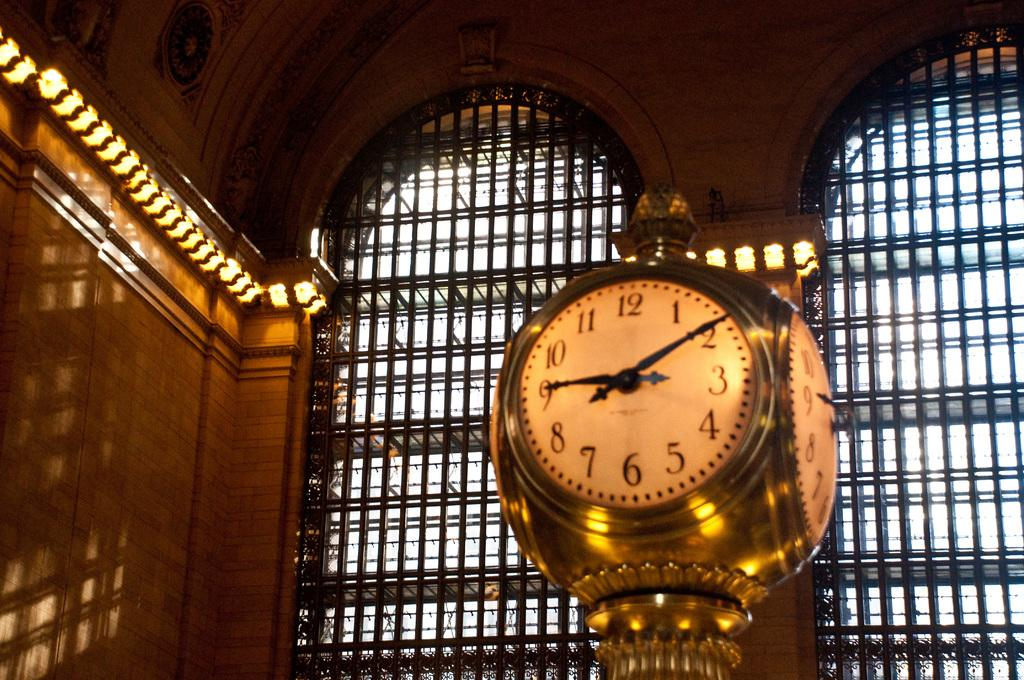<image>
Give a short and clear explanation of the subsequent image. The arms on a gold clock in a large building  strike 9 and 2. 